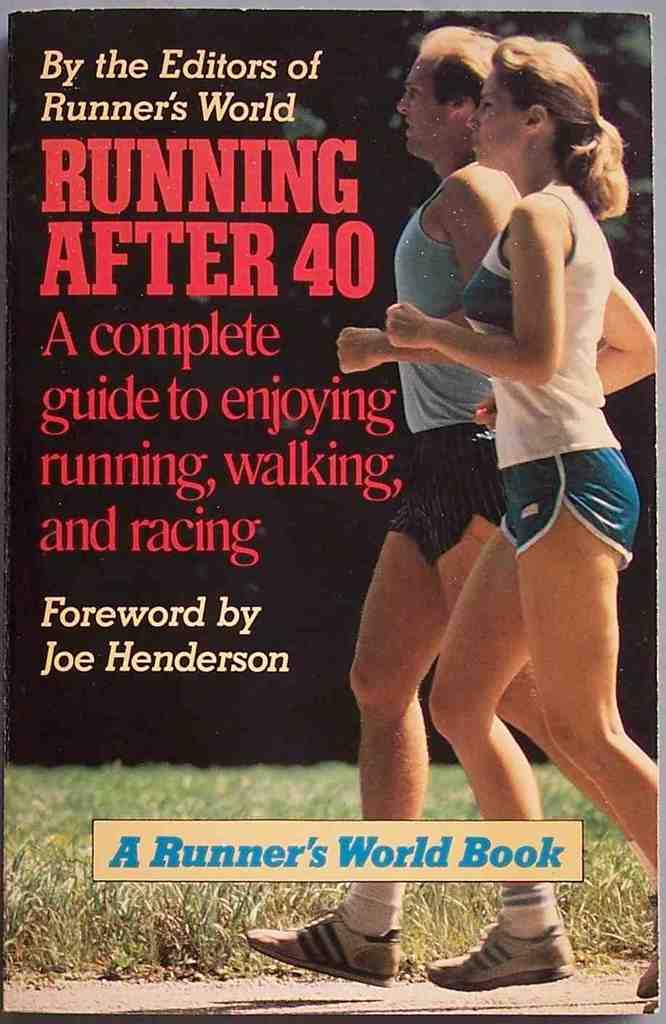What is the title of the blue book?
Provide a short and direct response. A runner's world book. 